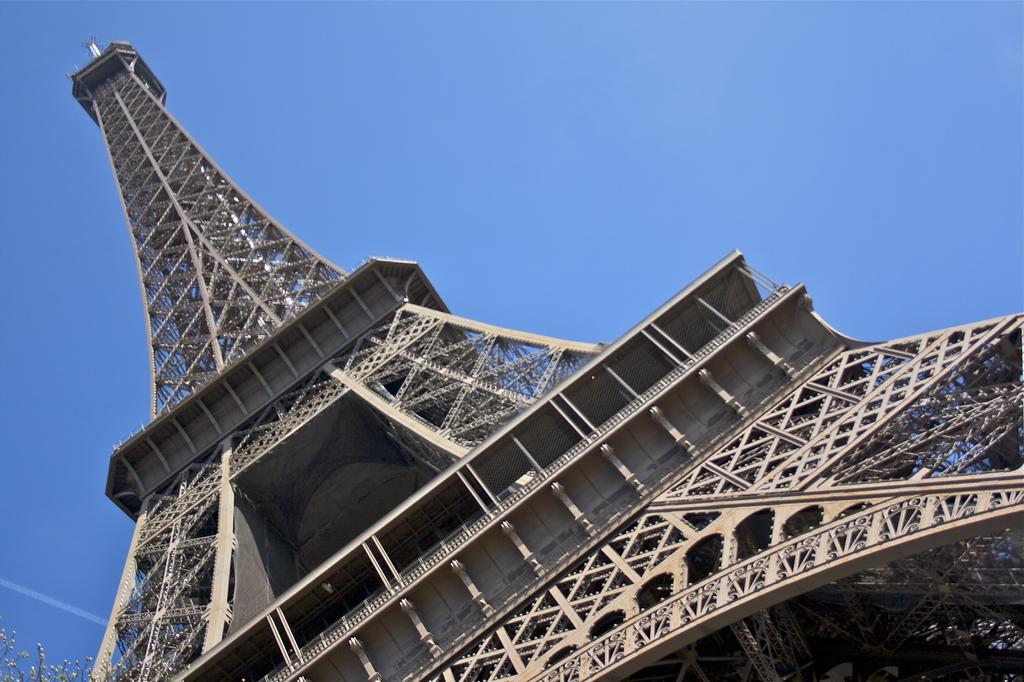What is the main structure in the image? There is a tower in the image. What can be seen in the background of the image? The sky is visible in the background of the image. How many wrens can be seen taking a bite out of the tower in the image? There are no wrens present in the image, and therefore no such activity can be observed. 